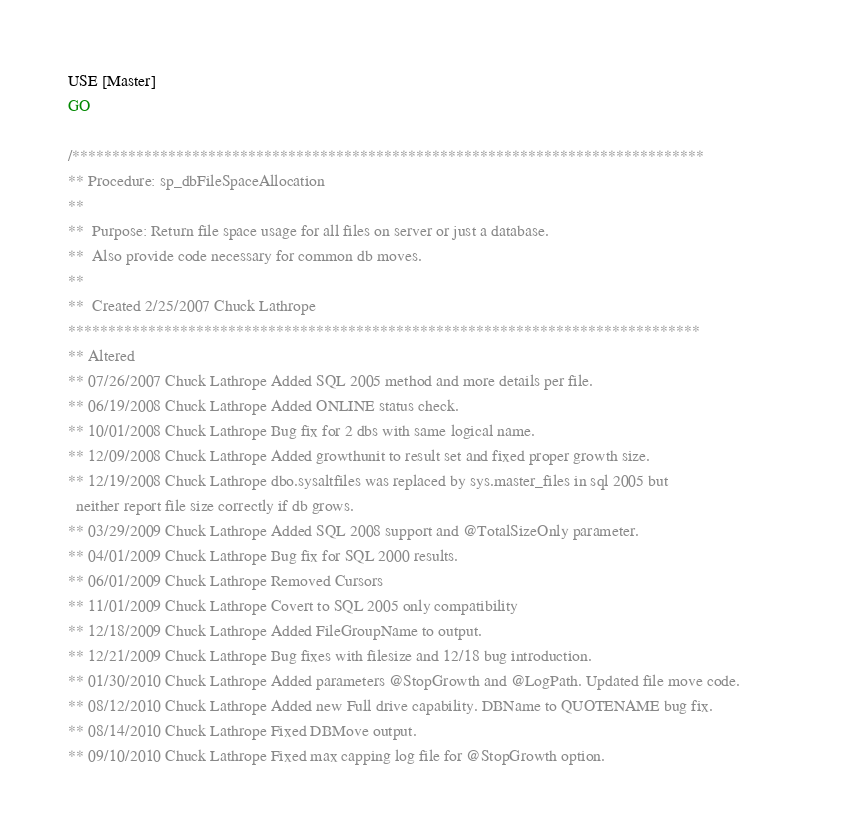Convert code to text. <code><loc_0><loc_0><loc_500><loc_500><_SQL_>USE [Master]
GO

/*******************************************************************************            
** Procedure: sp_dbFileSpaceAllocation          
**            
**  Purpose: Return file space usage for all files on server or just a database.            
**  Also provide code necessary for common db moves.            
**            
**  Created 2/25/2007 Chuck Lathrope            
*******************************************************************************            
** Altered            
** 07/26/2007 Chuck Lathrope Added SQL 2005 method and more details per file.            
** 06/19/2008 Chuck Lathrope Added ONLINE status check.            
** 10/01/2008 Chuck Lathrope Bug fix for 2 dbs with same logical name.            
** 12/09/2008 Chuck Lathrope Added growthunit to result set and fixed proper growth size.            
** 12/19/2008 Chuck Lathrope dbo.sysaltfiles was replaced by sys.master_files in sql 2005 but           
  neither report file size correctly if db grows.            
** 03/29/2009 Chuck Lathrope Added SQL 2008 support and @TotalSizeOnly parameter.            
** 04/01/2009 Chuck Lathrope Bug fix for SQL 2000 results.            
** 06/01/2009 Chuck Lathrope Removed Cursors            
** 11/01/2009 Chuck Lathrope Covert to SQL 2005 only compatibility          
** 12/18/2009 Chuck Lathrope Added FileGroupName to output.          
** 12/21/2009 Chuck Lathrope Bug fixes with filesize and 12/18 bug introduction.          
** 01/30/2010 Chuck Lathrope Added parameters @StopGrowth and @LogPath. Updated file move code.          
** 08/12/2010 Chuck Lathrope Added new Full drive capability. DBName to QUOTENAME bug fix.          
** 08/14/2010 Chuck Lathrope Fixed DBMove output.          
** 09/10/2010 Chuck Lathrope Fixed max capping log file for @StopGrowth option.          </code> 